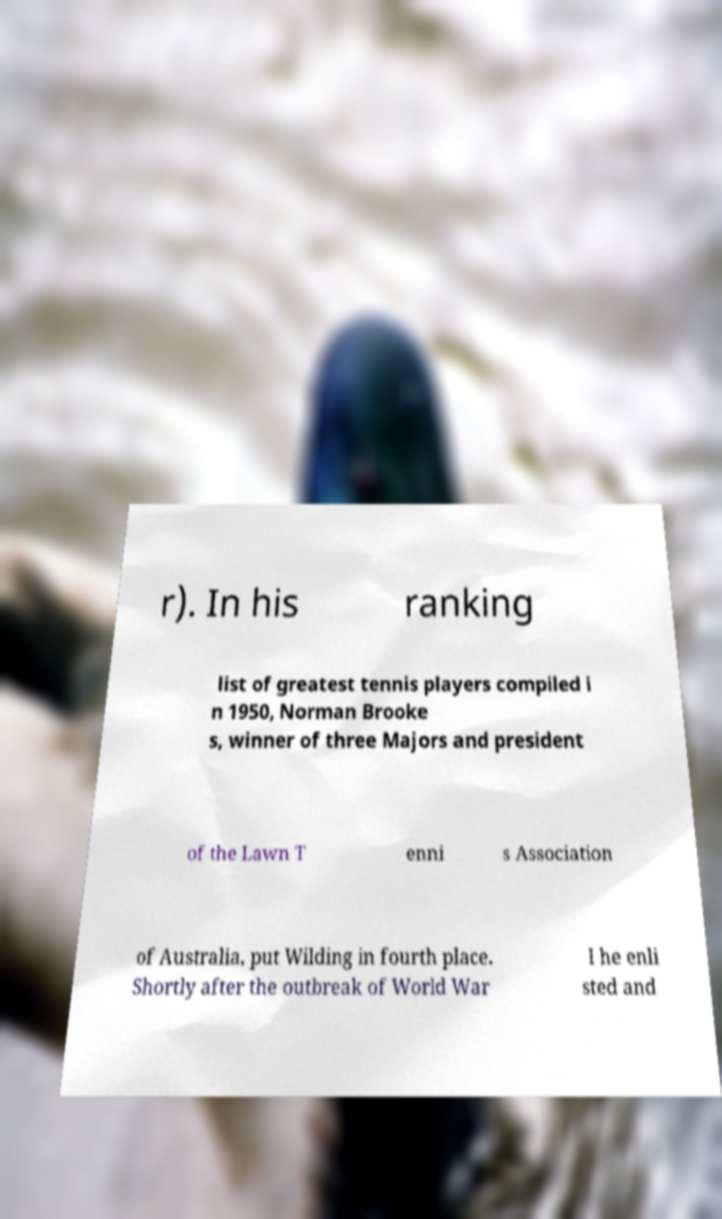Can you read and provide the text displayed in the image?This photo seems to have some interesting text. Can you extract and type it out for me? r). In his ranking list of greatest tennis players compiled i n 1950, Norman Brooke s, winner of three Majors and president of the Lawn T enni s Association of Australia, put Wilding in fourth place. Shortly after the outbreak of World War I he enli sted and 